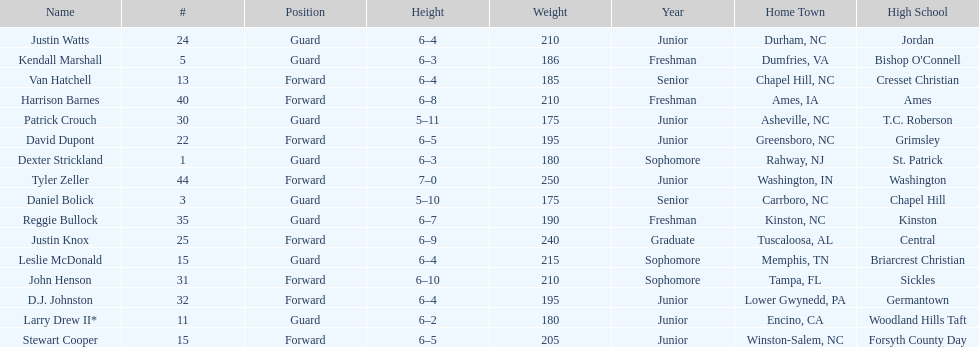Tallest player on the team Tyler Zeller. 